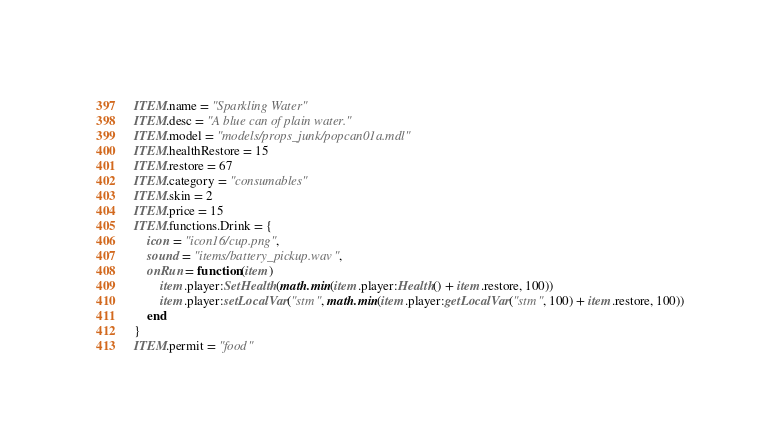Convert code to text. <code><loc_0><loc_0><loc_500><loc_500><_Lua_>ITEM.name = "Sparkling Water"
ITEM.desc = "A blue can of plain water."
ITEM.model = "models/props_junk/popcan01a.mdl"
ITEM.healthRestore = 15
ITEM.restore = 67
ITEM.category = "consumables"
ITEM.skin = 2
ITEM.price = 15
ITEM.functions.Drink = {
	icon = "icon16/cup.png",
	sound = "items/battery_pickup.wav",
	onRun = function(item)
		item.player:SetHealth(math.min(item.player:Health() + item.restore, 100))
		item.player:setLocalVar("stm", math.min(item.player:getLocalVar("stm", 100) + item.restore, 100))
	end
}
ITEM.permit = "food"</code> 